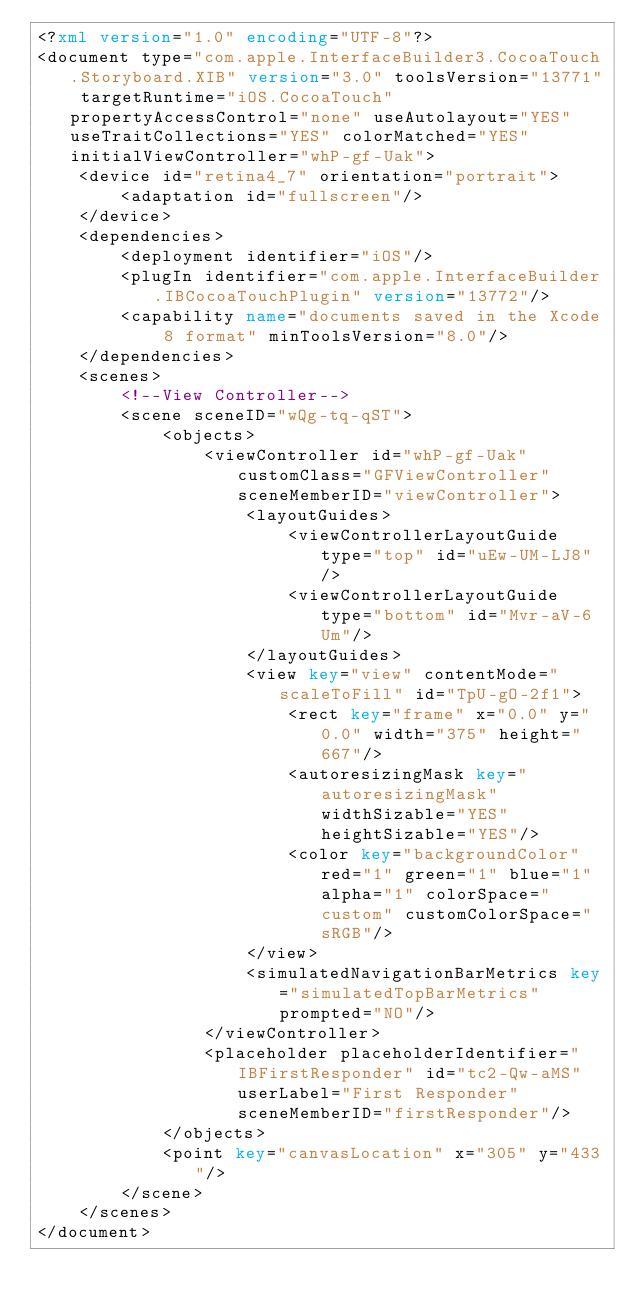<code> <loc_0><loc_0><loc_500><loc_500><_XML_><?xml version="1.0" encoding="UTF-8"?>
<document type="com.apple.InterfaceBuilder3.CocoaTouch.Storyboard.XIB" version="3.0" toolsVersion="13771" targetRuntime="iOS.CocoaTouch" propertyAccessControl="none" useAutolayout="YES" useTraitCollections="YES" colorMatched="YES" initialViewController="whP-gf-Uak">
    <device id="retina4_7" orientation="portrait">
        <adaptation id="fullscreen"/>
    </device>
    <dependencies>
        <deployment identifier="iOS"/>
        <plugIn identifier="com.apple.InterfaceBuilder.IBCocoaTouchPlugin" version="13772"/>
        <capability name="documents saved in the Xcode 8 format" minToolsVersion="8.0"/>
    </dependencies>
    <scenes>
        <!--View Controller-->
        <scene sceneID="wQg-tq-qST">
            <objects>
                <viewController id="whP-gf-Uak" customClass="GFViewController" sceneMemberID="viewController">
                    <layoutGuides>
                        <viewControllerLayoutGuide type="top" id="uEw-UM-LJ8"/>
                        <viewControllerLayoutGuide type="bottom" id="Mvr-aV-6Um"/>
                    </layoutGuides>
                    <view key="view" contentMode="scaleToFill" id="TpU-gO-2f1">
                        <rect key="frame" x="0.0" y="0.0" width="375" height="667"/>
                        <autoresizingMask key="autoresizingMask" widthSizable="YES" heightSizable="YES"/>
                        <color key="backgroundColor" red="1" green="1" blue="1" alpha="1" colorSpace="custom" customColorSpace="sRGB"/>
                    </view>
                    <simulatedNavigationBarMetrics key="simulatedTopBarMetrics" prompted="NO"/>
                </viewController>
                <placeholder placeholderIdentifier="IBFirstResponder" id="tc2-Qw-aMS" userLabel="First Responder" sceneMemberID="firstResponder"/>
            </objects>
            <point key="canvasLocation" x="305" y="433"/>
        </scene>
    </scenes>
</document>
</code> 